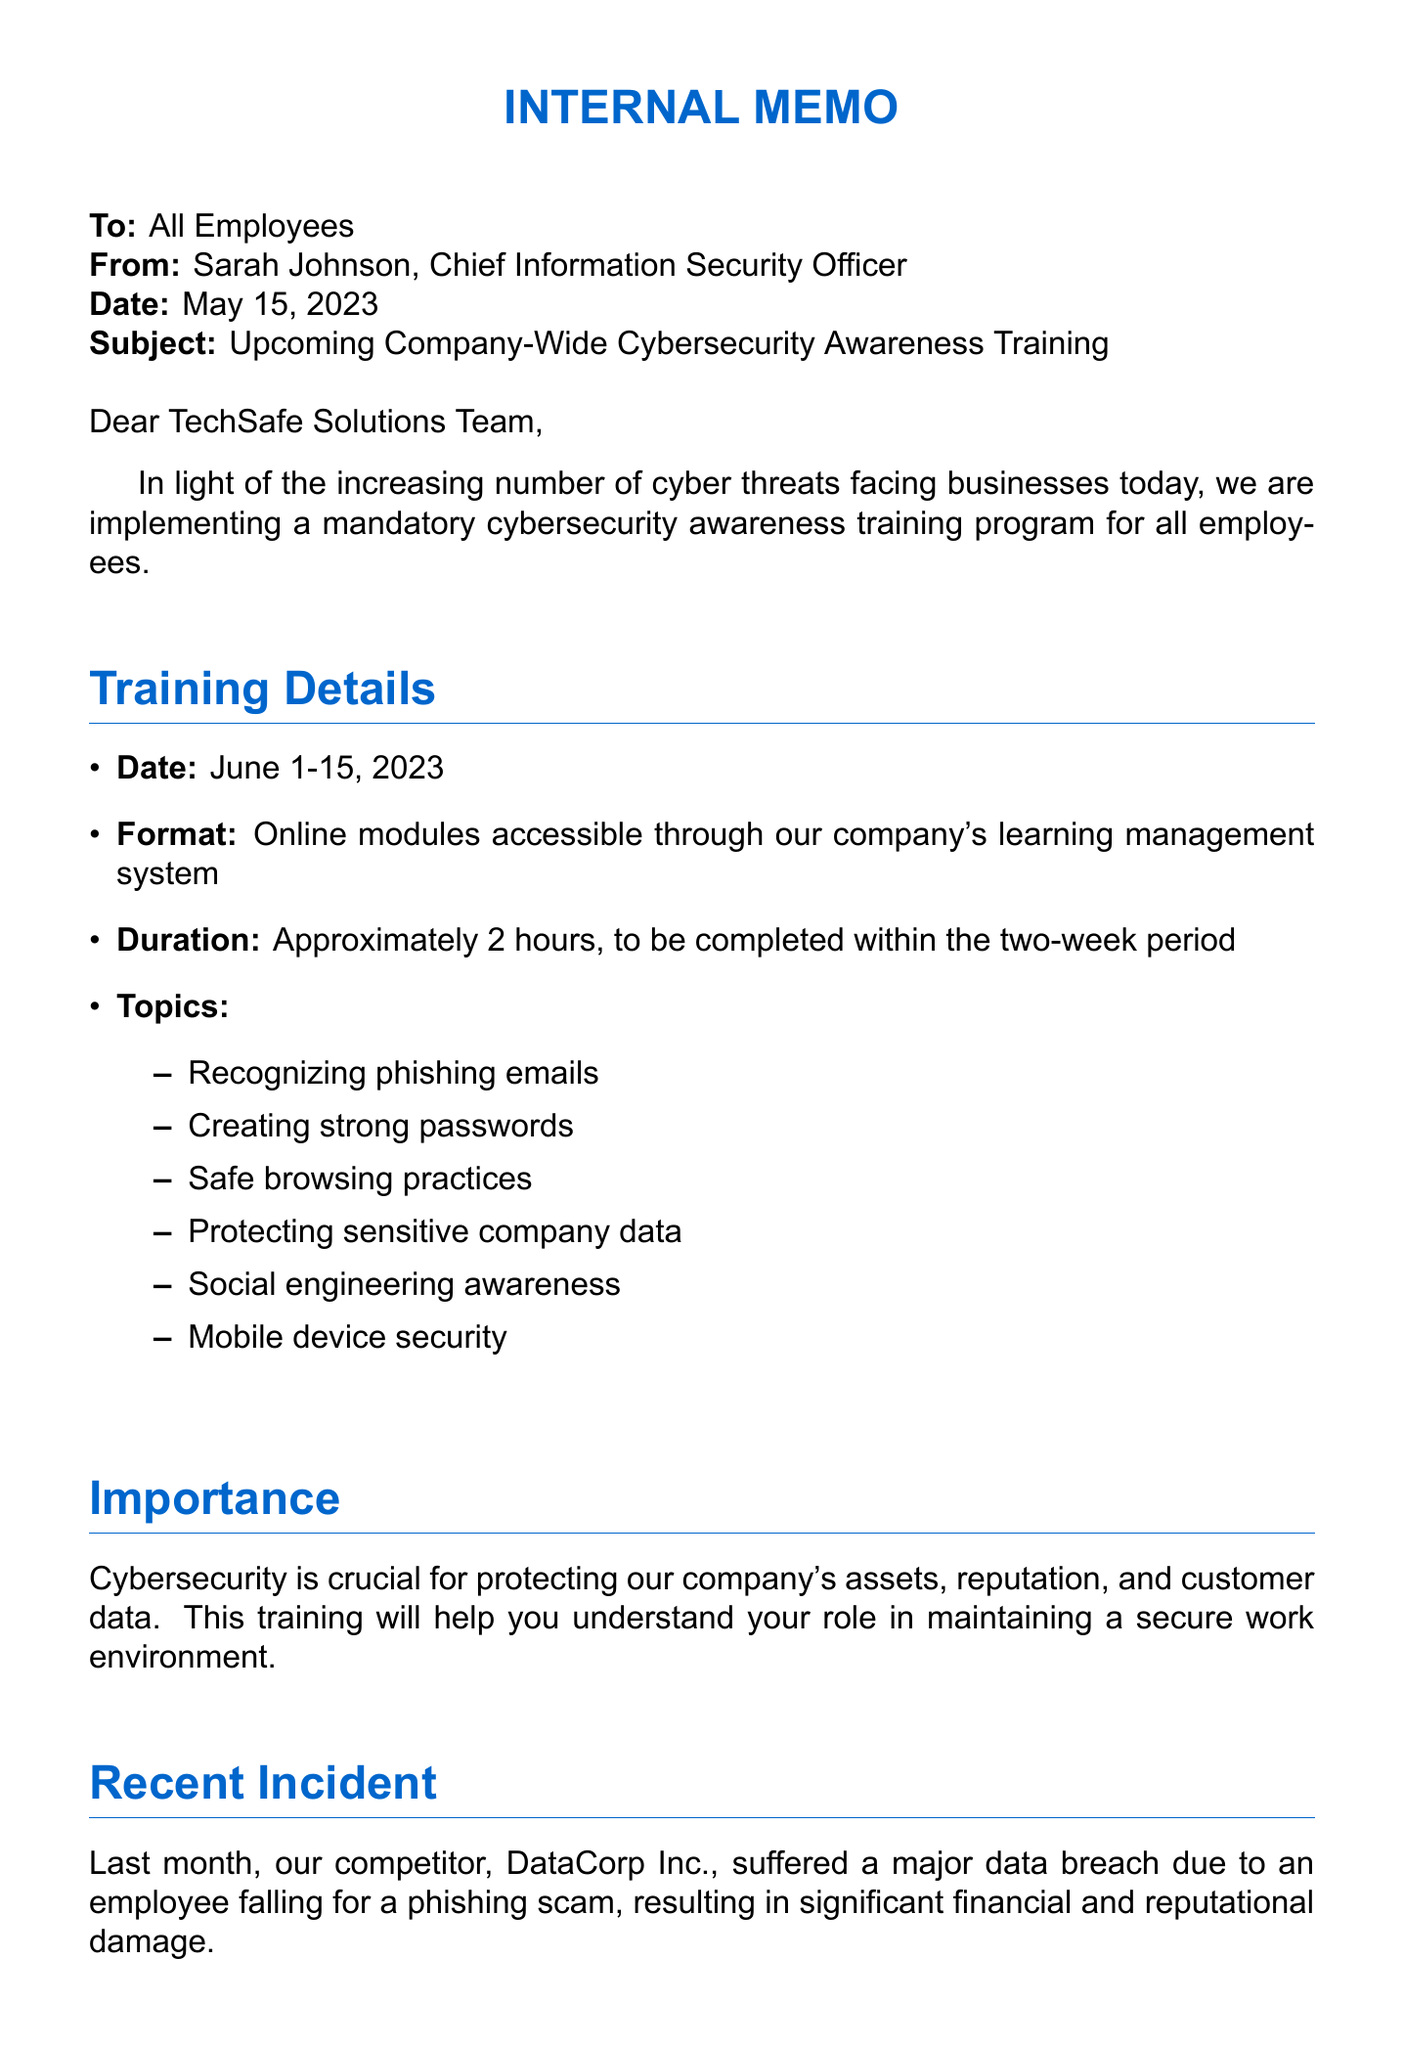What is the name of the company? The name of the company is mentioned in the memo header as TechSafe Solutions.
Answer: TechSafe Solutions Who is the sender of the memo? The sender's name and title are identified in the document as Sarah Johnson, Chief Information Security Officer.
Answer: Sarah Johnson When does the training take place? The training dates are specified in the document under "Training Details" as June 1-15, 2023.
Answer: June 1-15, 2023 What is the duration of the training? The duration of the training is mentioned in the "Training Details" section as approximately 2 hours.
Answer: Approximately 2 hours What important recent incident is referenced in the memo? The memo mentions a recent incident involving DataCorp Inc. and a data breach due to phishing.
Answer: Data breach at DataCorp Inc What will employees receive upon completion of the training? The document states that employees will receive a certificate of completion for their records.
Answer: Certificate of completion Why is the training being implemented? The memo explains that the training is being implemented due to the increasing number of cyber threats facing businesses today.
Answer: Increasing number of cyber threats What support is available for questions or technical issues? The memo provides contact information for IT Helpdesk for any questions or technical issues.
Answer: IT Helpdesk What is the deadline for completing the training? The deadline for training completion is outlined in the "Completion Requirements" section as June 15, 2023.
Answer: June 15, 2023 